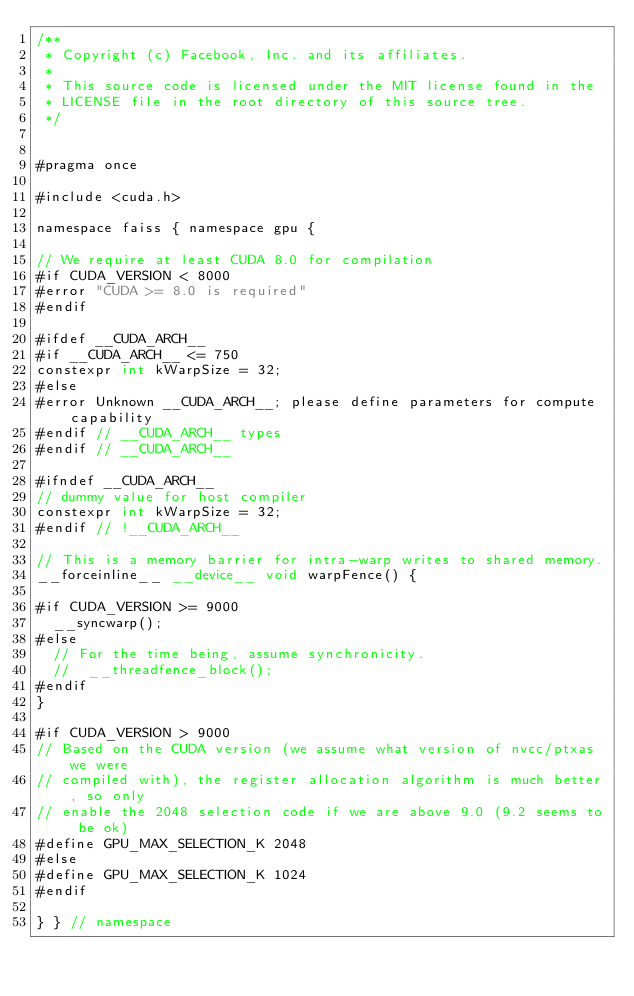Convert code to text. <code><loc_0><loc_0><loc_500><loc_500><_Cuda_>/**
 * Copyright (c) Facebook, Inc. and its affiliates.
 *
 * This source code is licensed under the MIT license found in the
 * LICENSE file in the root directory of this source tree.
 */


#pragma once

#include <cuda.h>

namespace faiss { namespace gpu {

// We require at least CUDA 8.0 for compilation
#if CUDA_VERSION < 8000
#error "CUDA >= 8.0 is required"
#endif

#ifdef __CUDA_ARCH__
#if __CUDA_ARCH__ <= 750
constexpr int kWarpSize = 32;
#else
#error Unknown __CUDA_ARCH__; please define parameters for compute capability
#endif // __CUDA_ARCH__ types
#endif // __CUDA_ARCH__

#ifndef __CUDA_ARCH__
// dummy value for host compiler
constexpr int kWarpSize = 32;
#endif // !__CUDA_ARCH__

// This is a memory barrier for intra-warp writes to shared memory.
__forceinline__ __device__ void warpFence() {

#if CUDA_VERSION >= 9000
  __syncwarp();
#else
  // For the time being, assume synchronicity.
  //  __threadfence_block();
#endif
}

#if CUDA_VERSION > 9000
// Based on the CUDA version (we assume what version of nvcc/ptxas we were
// compiled with), the register allocation algorithm is much better, so only
// enable the 2048 selection code if we are above 9.0 (9.2 seems to be ok)
#define GPU_MAX_SELECTION_K 2048
#else
#define GPU_MAX_SELECTION_K 1024
#endif

} } // namespace
</code> 